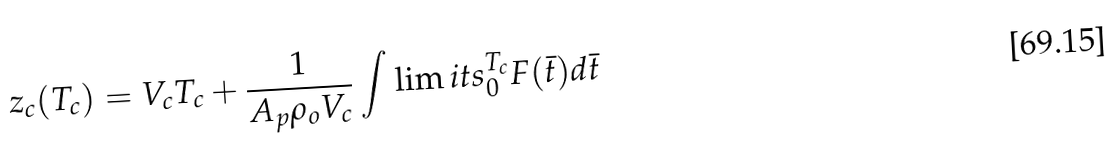<formula> <loc_0><loc_0><loc_500><loc_500>z _ { c } ( T _ { c } ) = V _ { c } T _ { c } + \frac { 1 } { A _ { p } \rho _ { o } V _ { c } } \int \lim i t s _ { 0 } ^ { T _ { c } } { F ( \bar { t } ) d \bar { t } }</formula> 